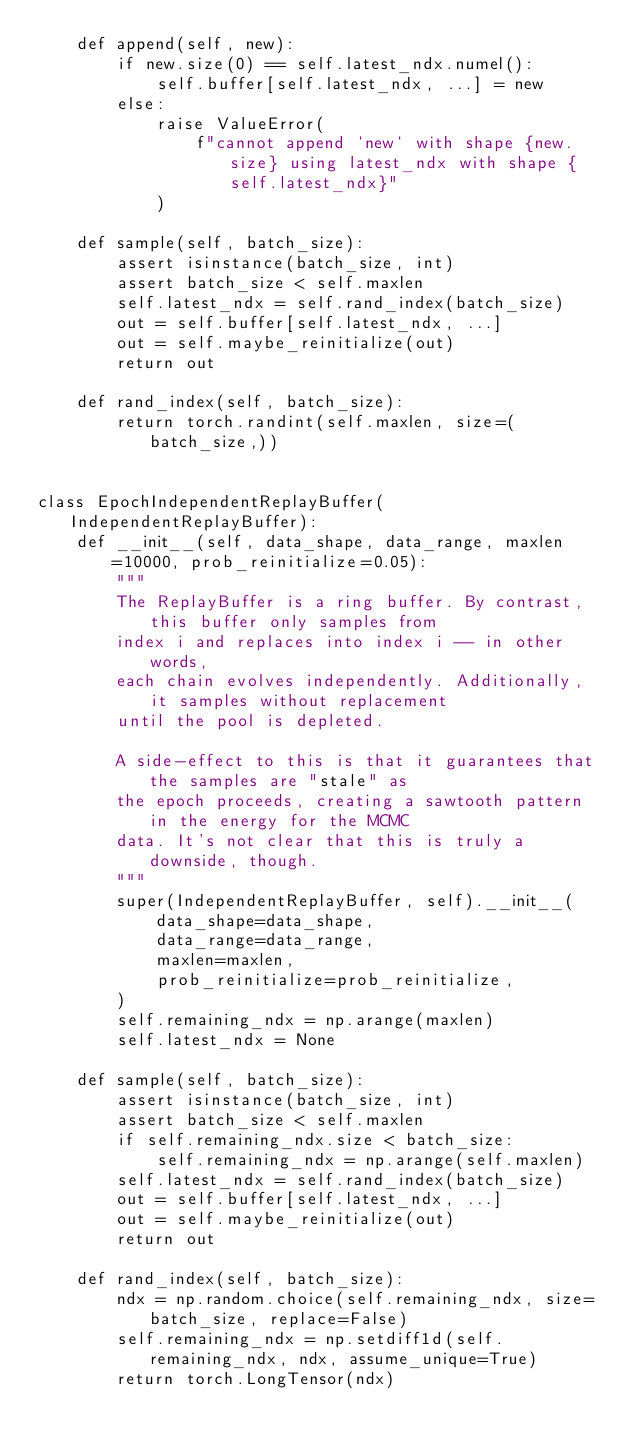<code> <loc_0><loc_0><loc_500><loc_500><_Python_>    def append(self, new):
        if new.size(0) == self.latest_ndx.numel():
            self.buffer[self.latest_ndx, ...] = new
        else:
            raise ValueError(
                f"cannot append `new` with shape {new.size} using latest_ndx with shape {self.latest_ndx}"
            )

    def sample(self, batch_size):
        assert isinstance(batch_size, int)
        assert batch_size < self.maxlen
        self.latest_ndx = self.rand_index(batch_size)
        out = self.buffer[self.latest_ndx, ...]
        out = self.maybe_reinitialize(out)
        return out

    def rand_index(self, batch_size):
        return torch.randint(self.maxlen, size=(batch_size,))


class EpochIndependentReplayBuffer(IndependentReplayBuffer):
    def __init__(self, data_shape, data_range, maxlen=10000, prob_reinitialize=0.05):
        """
        The ReplayBuffer is a ring buffer. By contrast, this buffer only samples from
        index i and replaces into index i -- in other words,
        each chain evolves independently. Additionally, it samples without replacement
        until the pool is depleted.

        A side-effect to this is that it guarantees that the samples are "stale" as
        the epoch proceeds, creating a sawtooth pattern in the energy for the MCMC
        data. It's not clear that this is truly a downside, though.
        """
        super(IndependentReplayBuffer, self).__init__(
            data_shape=data_shape,
            data_range=data_range,
            maxlen=maxlen,
            prob_reinitialize=prob_reinitialize,
        )
        self.remaining_ndx = np.arange(maxlen)
        self.latest_ndx = None

    def sample(self, batch_size):
        assert isinstance(batch_size, int)
        assert batch_size < self.maxlen
        if self.remaining_ndx.size < batch_size:
            self.remaining_ndx = np.arange(self.maxlen)
        self.latest_ndx = self.rand_index(batch_size)
        out = self.buffer[self.latest_ndx, ...]
        out = self.maybe_reinitialize(out)
        return out

    def rand_index(self, batch_size):
        ndx = np.random.choice(self.remaining_ndx, size=batch_size, replace=False)
        self.remaining_ndx = np.setdiff1d(self.remaining_ndx, ndx, assume_unique=True)
        return torch.LongTensor(ndx)
</code> 